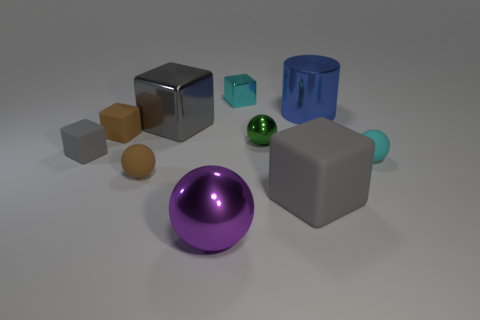Subtract all small cyan balls. How many balls are left? 3 Subtract all cyan cubes. How many cubes are left? 4 Subtract all balls. How many objects are left? 6 Subtract all blue cylinders. How many brown spheres are left? 1 Subtract all big yellow shiny blocks. Subtract all big shiny balls. How many objects are left? 9 Add 4 purple spheres. How many purple spheres are left? 5 Add 2 cyan cubes. How many cyan cubes exist? 3 Subtract 1 green spheres. How many objects are left? 9 Subtract 3 spheres. How many spheres are left? 1 Subtract all blue balls. Subtract all purple blocks. How many balls are left? 4 